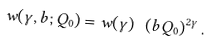Convert formula to latex. <formula><loc_0><loc_0><loc_500><loc_500>w ( \gamma , b ; Q _ { 0 } ) = w ( \gamma ) \ \left ( b Q _ { 0 } \right ) ^ { 2 \gamma } .</formula> 